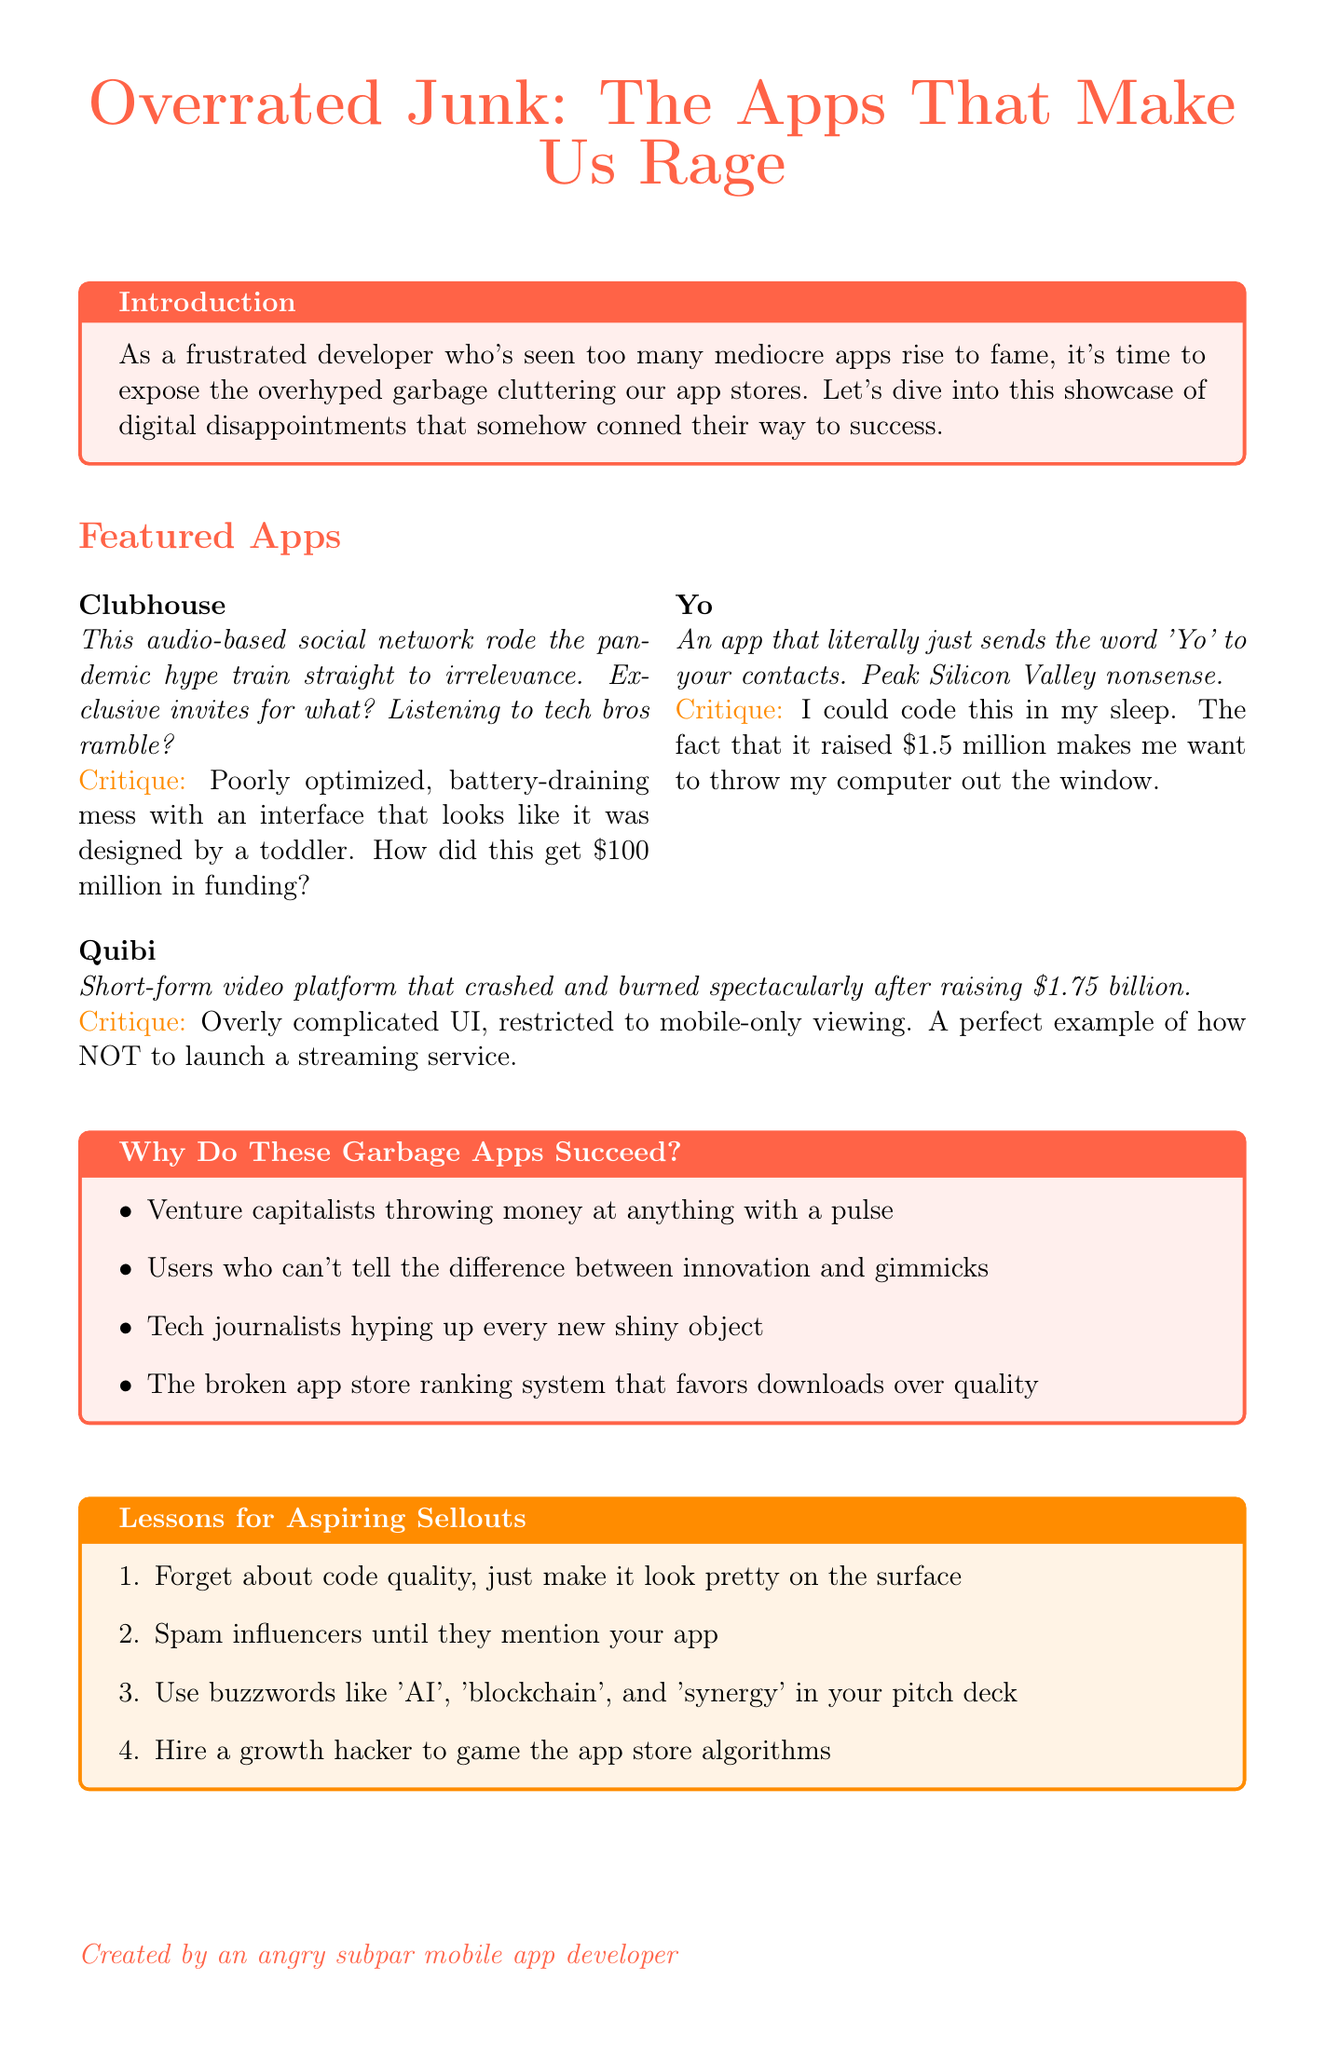what is the title of the newsletter? The title of the newsletter is stated at the beginning of the document.
Answer: Overrated Junk: The Apps That Make Us Rage how many featured apps are there? The number of featured apps is listed in the document's section about featured apps.
Answer: 3 who is the first featured app? This information is available in the featured apps section of the newsletter.
Answer: Clubhouse what amount did Yo raise? The amount raised by Yo is mentioned in the critique section specifically related to that app.
Answer: $1.5 million what is the main critique of Quibi? The critique provided discusses the shortcomings of Quibi in the document.
Answer: Overly complicated UI, restricted to mobile-only viewing what is one reason for the success of garbage apps? This is found in the rant section, which lists reasons for the success of these apps.
Answer: Venture capitalists throwing money at anything with a pulse what should aspiring sellouts focus on according to the lessons? The lessons section contains advice for developers looking to succeed in the current app landscape.
Answer: Forget about code quality, just make it look pretty on the surface how much did Quibi raise? The funding amount for Quibi is noted in the app's description section.
Answer: $1.75 billion what is the conclusion about overhyped apps? The conclusion summarizes the overall sentiment towards the discussed apps.
Answer: Let's channel our rage into creating genuinely useful apps 